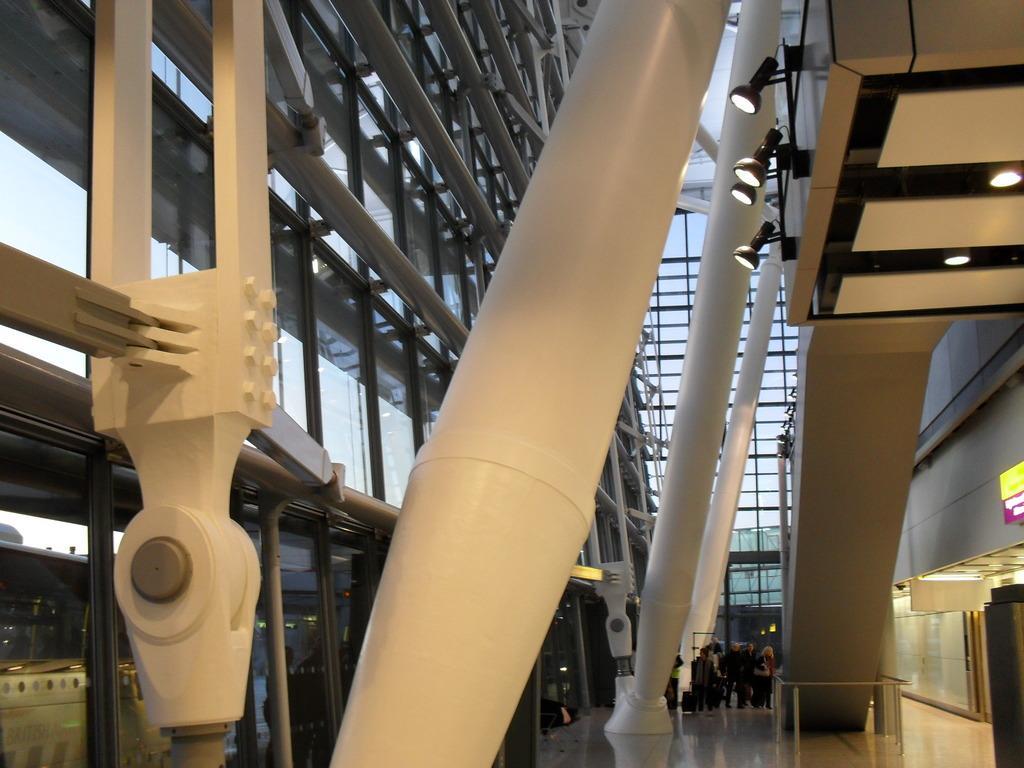In one or two sentences, can you explain what this image depicts? In this picture I can see inner view of a building, I can see few lights and few people standing and I can see glasses to the building ad looks like a staircase. 